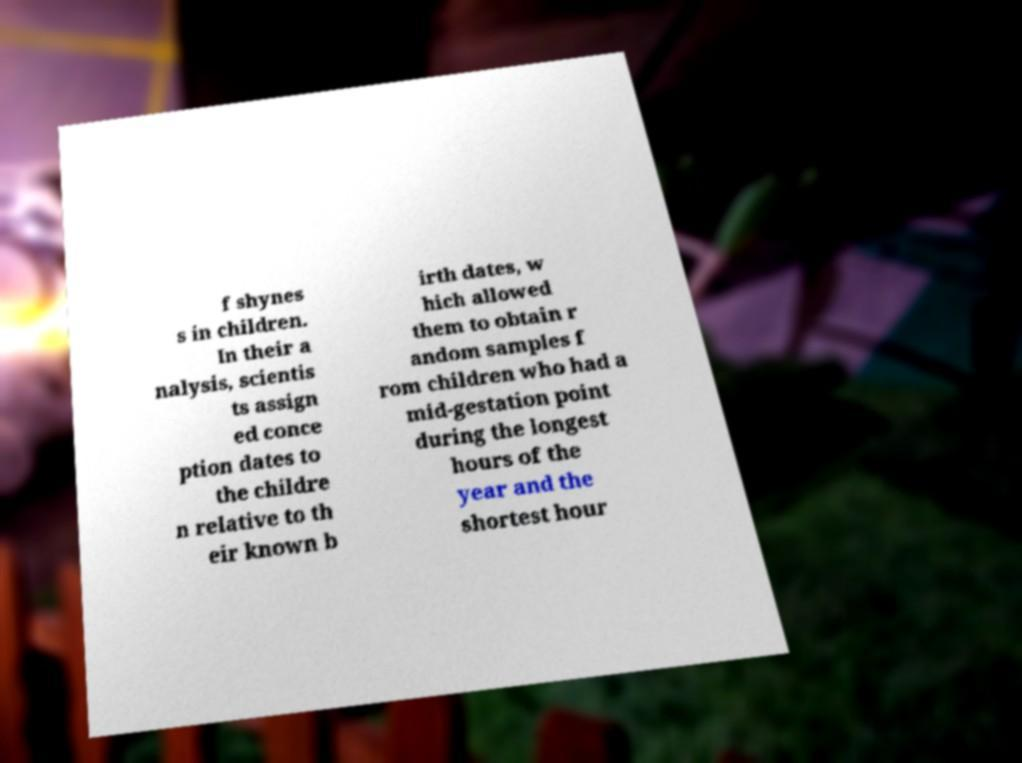What messages or text are displayed in this image? I need them in a readable, typed format. f shynes s in children. In their a nalysis, scientis ts assign ed conce ption dates to the childre n relative to th eir known b irth dates, w hich allowed them to obtain r andom samples f rom children who had a mid-gestation point during the longest hours of the year and the shortest hour 